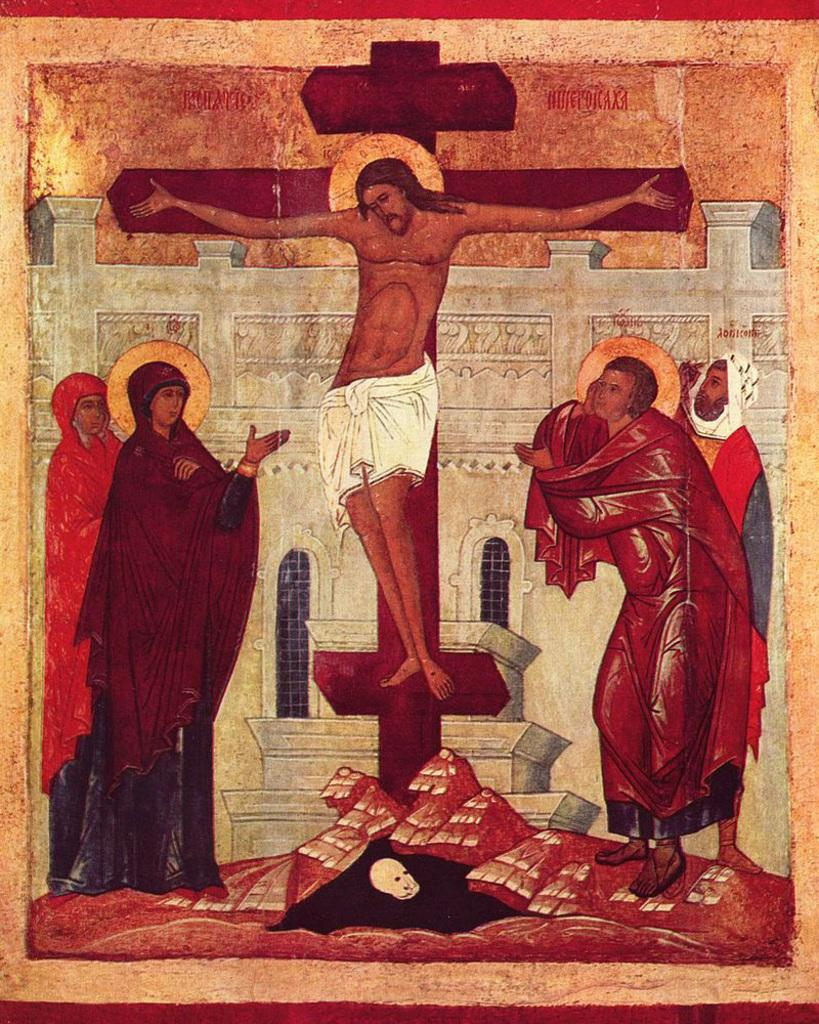What is depicted in the image involving people? There is a drawing of people in the image. What type of structure can be seen in the image? There is a building with windows in the image. What symbol is present in the image? There is a cross sign in the image. How many needles are being exchanged between the people in the image? There are no needles or exchange of items depicted in the image; it features a drawing of people, a building with windows, and a cross sign. What nation is represented by the people in the image? The image does not specify a nation or nationality for the people depicted. 